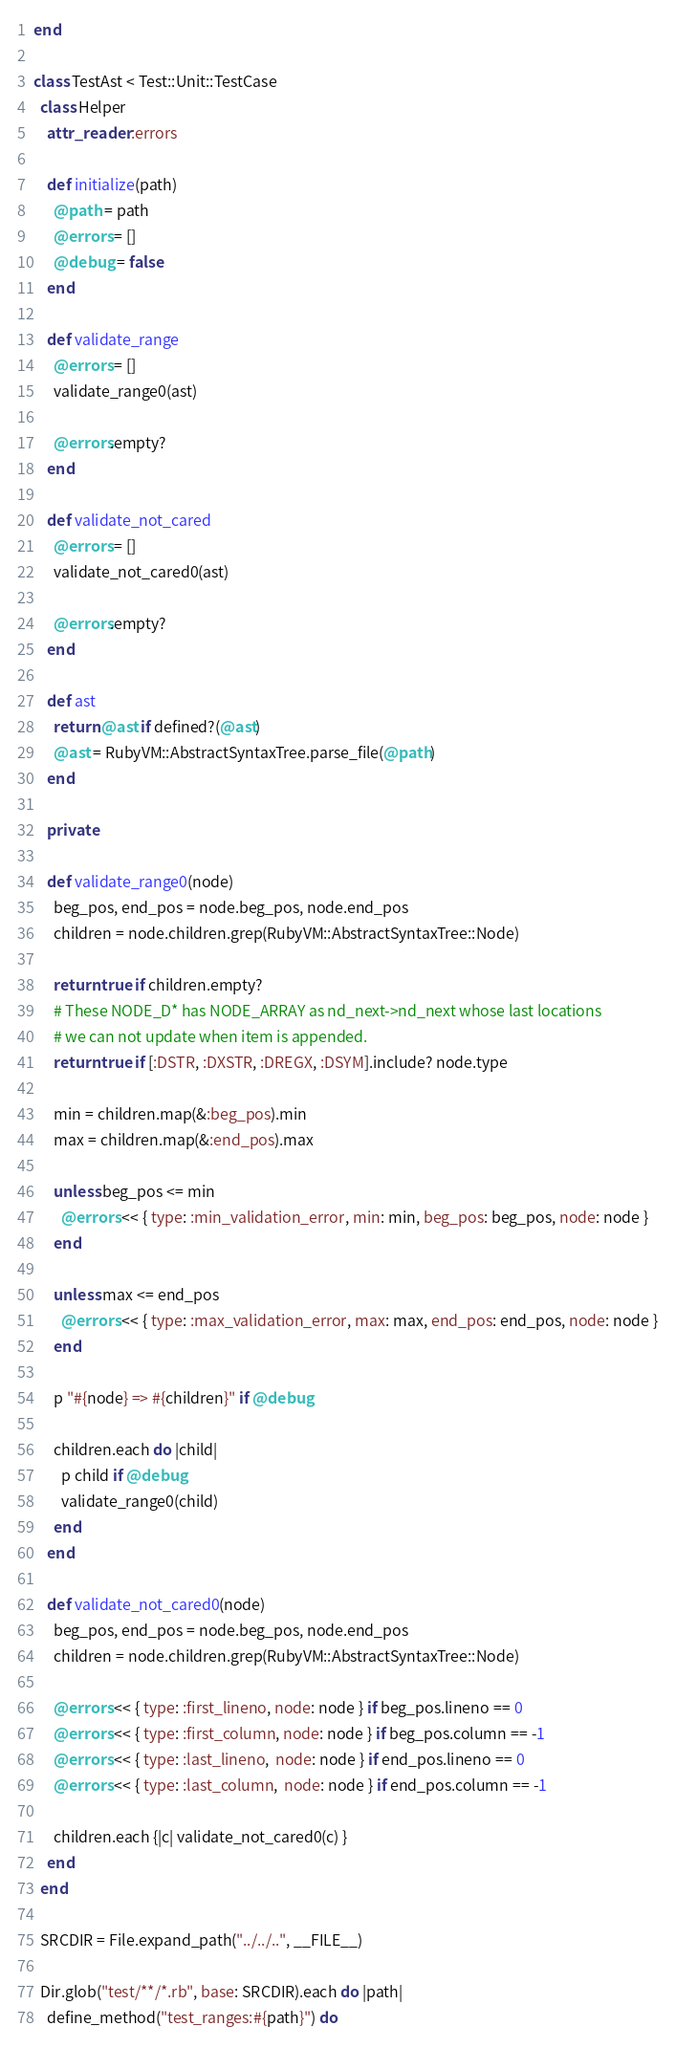Convert code to text. <code><loc_0><loc_0><loc_500><loc_500><_Ruby_>end

class TestAst < Test::Unit::TestCase
  class Helper
    attr_reader :errors

    def initialize(path)
      @path = path
      @errors = []
      @debug = false
    end

    def validate_range
      @errors = []
      validate_range0(ast)

      @errors.empty?
    end

    def validate_not_cared
      @errors = []
      validate_not_cared0(ast)

      @errors.empty?
    end

    def ast
      return @ast if defined?(@ast)
      @ast = RubyVM::AbstractSyntaxTree.parse_file(@path)
    end

    private

    def validate_range0(node)
      beg_pos, end_pos = node.beg_pos, node.end_pos
      children = node.children.grep(RubyVM::AbstractSyntaxTree::Node)

      return true if children.empty?
      # These NODE_D* has NODE_ARRAY as nd_next->nd_next whose last locations
      # we can not update when item is appended.
      return true if [:DSTR, :DXSTR, :DREGX, :DSYM].include? node.type

      min = children.map(&:beg_pos).min
      max = children.map(&:end_pos).max

      unless beg_pos <= min
        @errors << { type: :min_validation_error, min: min, beg_pos: beg_pos, node: node }
      end

      unless max <= end_pos
        @errors << { type: :max_validation_error, max: max, end_pos: end_pos, node: node }
      end

      p "#{node} => #{children}" if @debug

      children.each do |child|
        p child if @debug
        validate_range0(child)
      end
    end

    def validate_not_cared0(node)
      beg_pos, end_pos = node.beg_pos, node.end_pos
      children = node.children.grep(RubyVM::AbstractSyntaxTree::Node)

      @errors << { type: :first_lineno, node: node } if beg_pos.lineno == 0
      @errors << { type: :first_column, node: node } if beg_pos.column == -1
      @errors << { type: :last_lineno,  node: node } if end_pos.lineno == 0
      @errors << { type: :last_column,  node: node } if end_pos.column == -1

      children.each {|c| validate_not_cared0(c) }
    end
  end

  SRCDIR = File.expand_path("../../..", __FILE__)

  Dir.glob("test/**/*.rb", base: SRCDIR).each do |path|
    define_method("test_ranges:#{path}") do</code> 